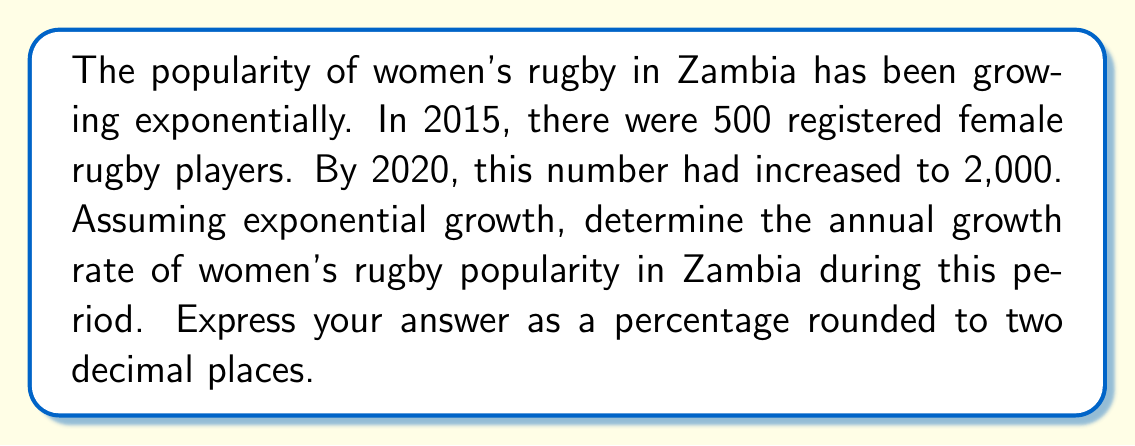Provide a solution to this math problem. Let's approach this step-by-step using the exponential growth formula:

1) The exponential growth formula is:
   $A = P(1 + r)^t$
   Where:
   $A$ = Final amount
   $P$ = Initial amount
   $r$ = Annual growth rate (in decimal form)
   $t$ = Time period (in years)

2) We know:
   $P = 500$ (players in 2015)
   $A = 2000$ (players in 2020)
   $t = 5$ years (from 2015 to 2020)

3) Let's substitute these values into the formula:
   $2000 = 500(1 + r)^5$

4) Divide both sides by 500:
   $4 = (1 + r)^5$

5) Take the 5th root of both sides:
   $\sqrt[5]{4} = 1 + r$

6) Solve for $r$:
   $r = \sqrt[5]{4} - 1$

7) Calculate:
   $r = 1.3195 - 1 = 0.3195$

8) Convert to percentage:
   $0.3195 * 100 = 31.95\%$

9) Round to two decimal places:
   $31.95\%$
Answer: 31.95% 